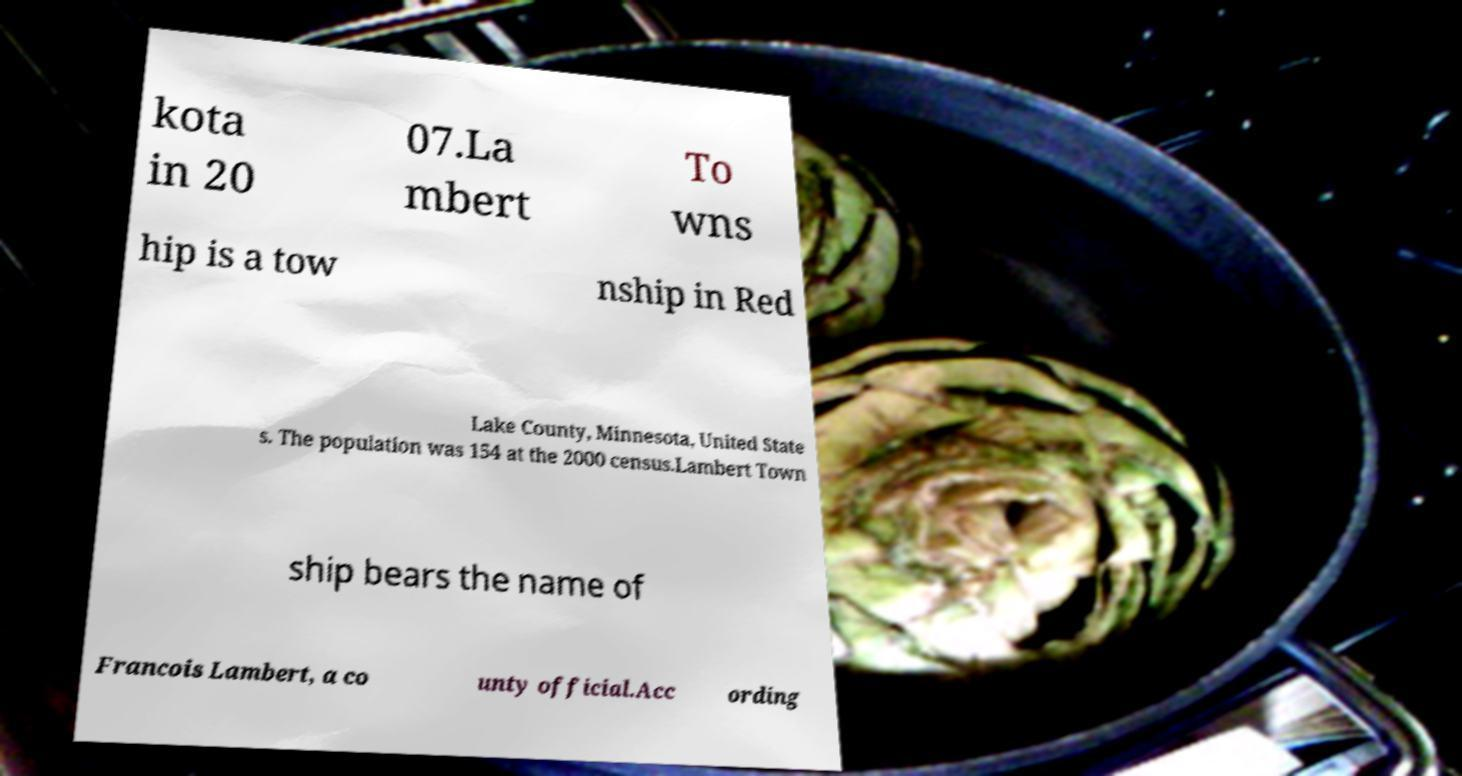Please identify and transcribe the text found in this image. kota in 20 07.La mbert To wns hip is a tow nship in Red Lake County, Minnesota, United State s. The population was 154 at the 2000 census.Lambert Town ship bears the name of Francois Lambert, a co unty official.Acc ording 